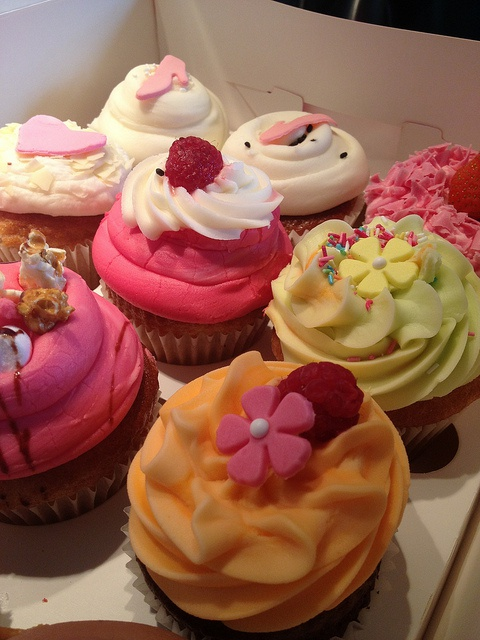Describe the objects in this image and their specific colors. I can see cake in darkgray, brown, maroon, and black tones, cake in darkgray, brown, maroon, salmon, and tan tones, cake in darkgray, tan, and olive tones, cake in darkgray, maroon, black, and brown tones, and cake in darkgray, lightgray, tan, and maroon tones in this image. 